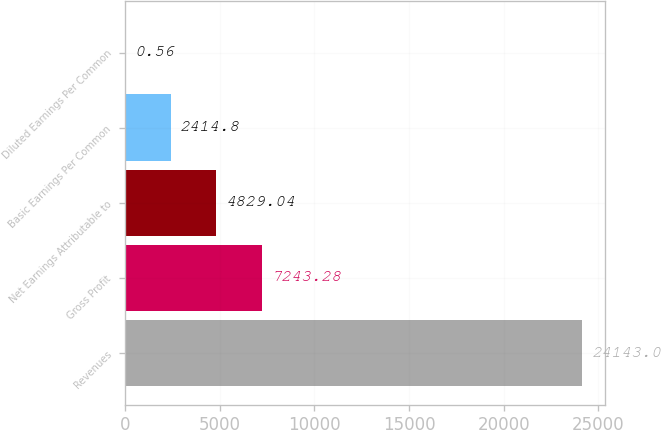Convert chart. <chart><loc_0><loc_0><loc_500><loc_500><bar_chart><fcel>Revenues<fcel>Gross Profit<fcel>Net Earnings Attributable to<fcel>Basic Earnings Per Common<fcel>Diluted Earnings Per Common<nl><fcel>24143<fcel>7243.28<fcel>4829.04<fcel>2414.8<fcel>0.56<nl></chart> 